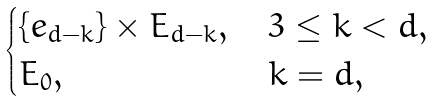Convert formula to latex. <formula><loc_0><loc_0><loc_500><loc_500>\begin{cases} \{ e _ { d - k } \} \times E _ { d - k } , \, & 3 \leq k < d , \\ E _ { 0 } , & k = d , \end{cases}</formula> 